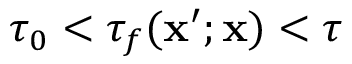Convert formula to latex. <formula><loc_0><loc_0><loc_500><loc_500>\tau _ { 0 } < \tau _ { f } ( x ^ { \prime } ; x ) < \tau</formula> 